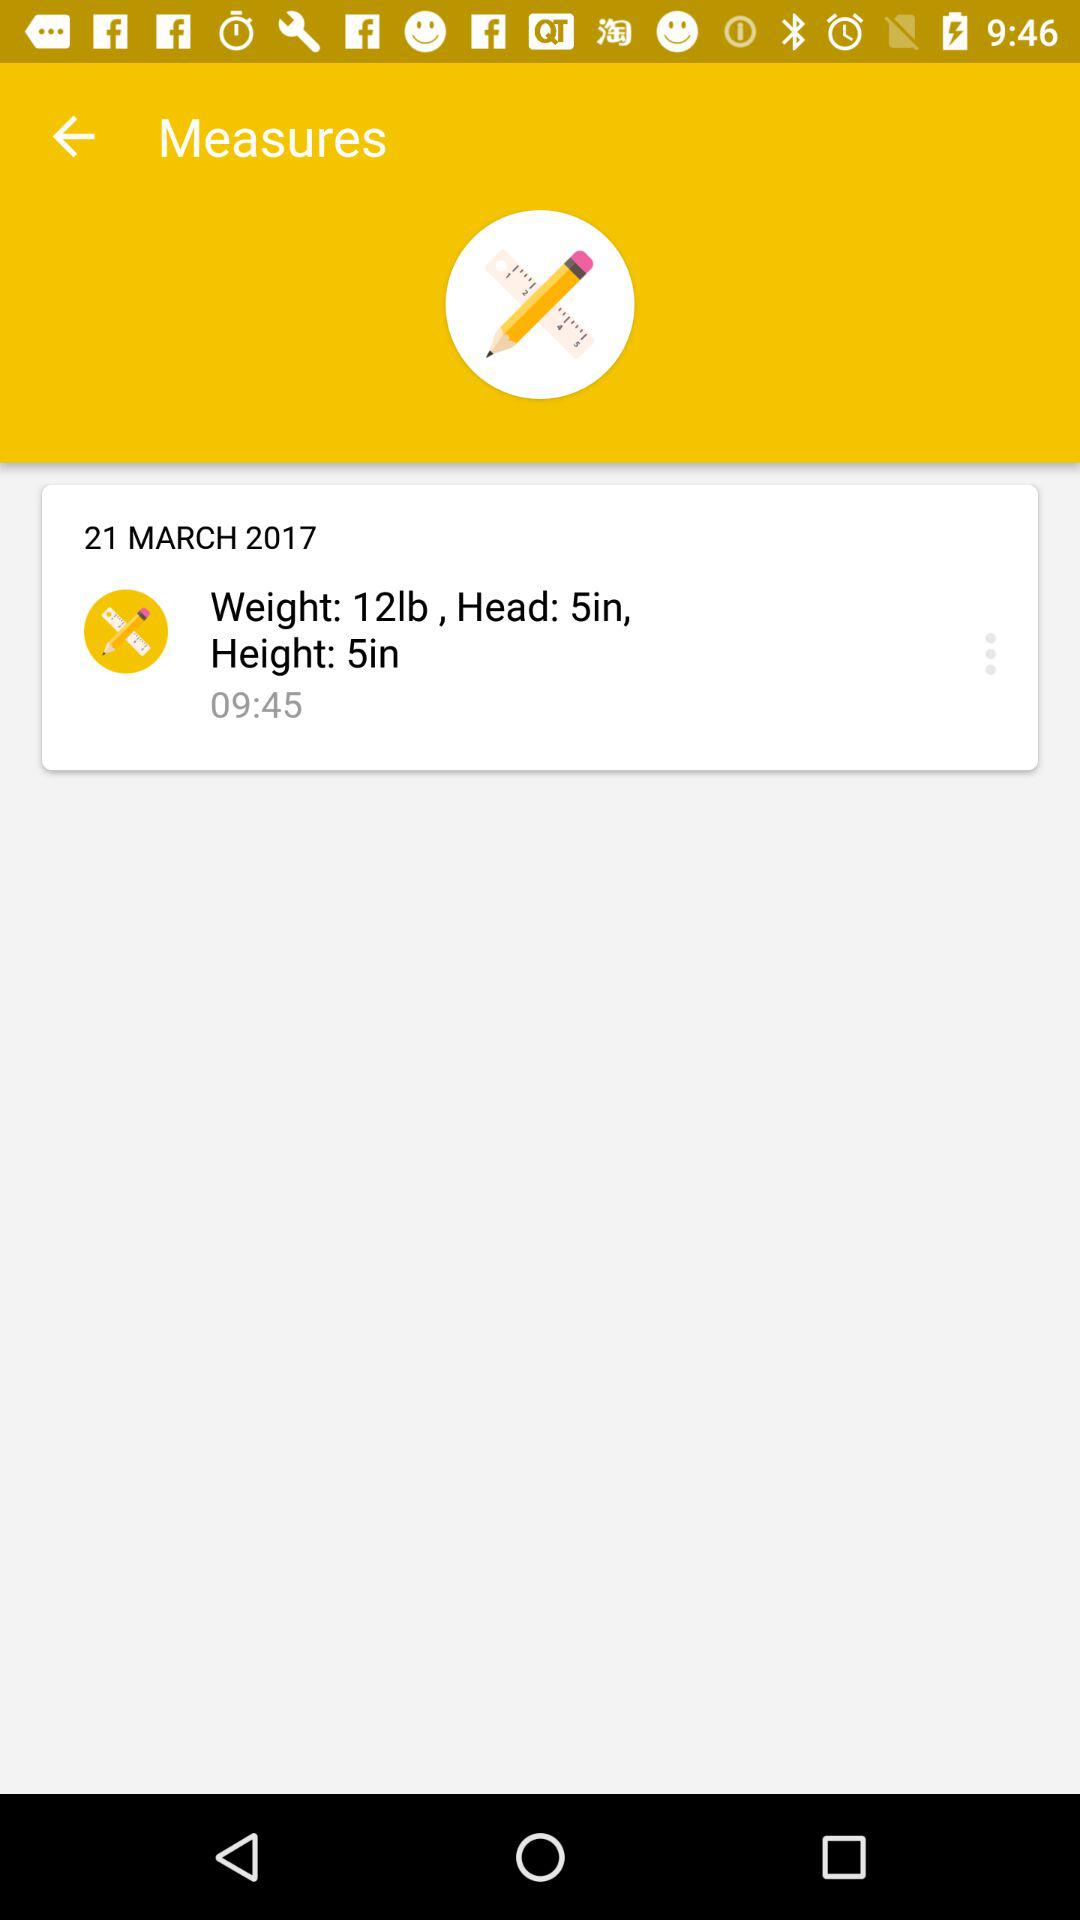What is the weight? The weight is 12 pounds. 